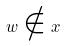Convert formula to latex. <formula><loc_0><loc_0><loc_500><loc_500>w \notin x</formula> 